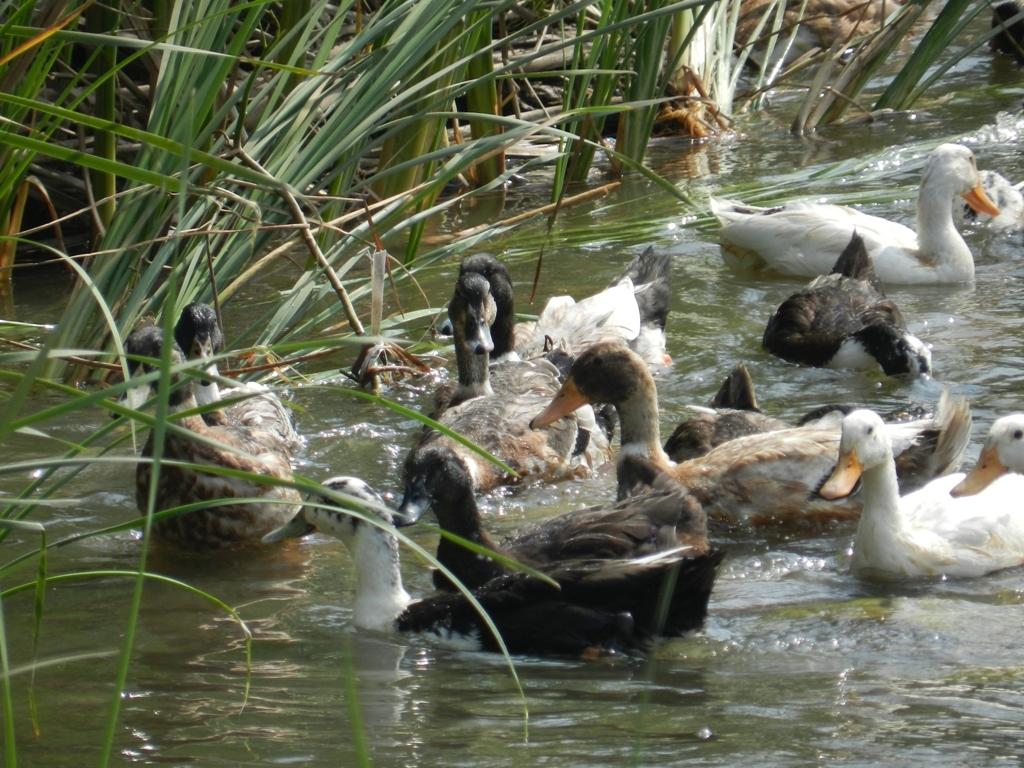What type of animals can be seen in the image? There are many birds in a water body in the image. What can be seen in the background of the image? There is grass visible in the background of the image. What type of silk fabric is being used to make the birds' nests in the image? There is no mention of silk fabric or nests in the image; it simply shows birds in a water body. 